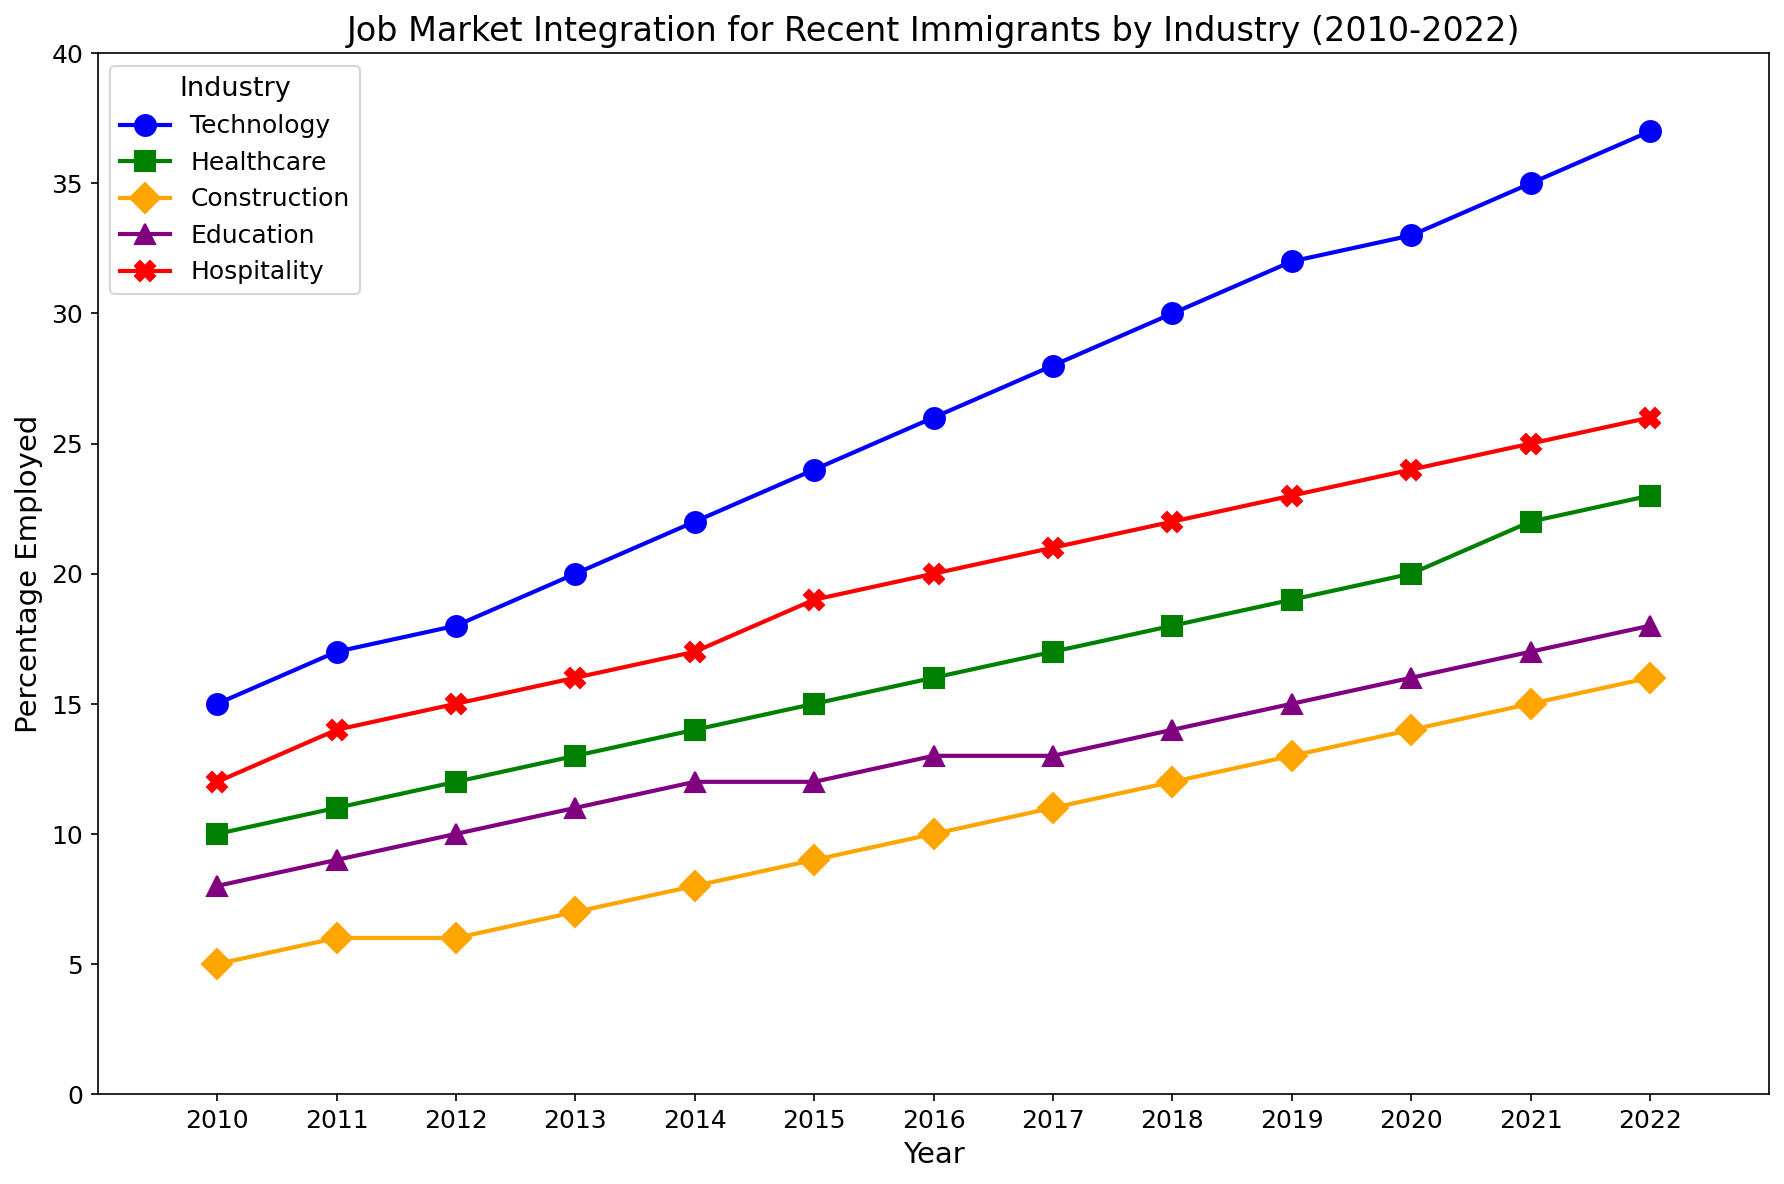Which industry had the highest percentage employed in 2022? Look at the year 2022 on the x-axis and compare the height of the lines for each industry. The line representing Technology reaches the highest point on the y-axis.
Answer: Technology Which industry saw the most significant increase in employment percentage from 2010 to 2022? Compare the percentage employed in 2010 and 2022 for each industry and find the difference. Technology increased from 15% to 37%, which is a difference of 22%.
Answer: Technology In which year did Hospitality first exceed 20% employment? Follow the Hospitality line (red with X markers) and find the year where it first crosses the 20% mark on the y-axis. This happens in 2017.
Answer: 2017 Compare the percentage employment in Education and Construction in 2015. Which one had a higher percentage? Look at the y-values for Education (purple with ^ markers) and Construction (orange with D markers) in 2015. Education is at 12%, while Construction is at 9%.
Answer: Education What is the average employment percentage in Healthcare from 2010 to 2022? Sum the employment percentages for Healthcare (green with s markers) for all years and divide by the number of years (13). (10 + 11 + 12 + 13 + 14 + 15 + 16 + 17 + 18 + 19 + 20 + 22 + 23) / 13 = 15.69%
Answer: 15.69% By how much did the employment percentage in Construction increase from 2010 to 2016? Subtract the 2010 employment percentage in Construction (5%) from the 2016 percentage (10%). 10% - 5% = 5%
Answer: 5% In which year did Technology first reach 30% employment? Trace the Technology line (blue with o markers) to see when it first hits the 30% mark on the y-axis. This occurs in 2018.
Answer: 2018 Which two industries were closest in employment percentage in 2020? Look at the employment percentages for all industries in 2020 and find the two most similar values. Construction (14%) and Education (16%) are closest, with a difference of 2%.
Answer: Construction and Education How did the employment percentage in Hospitality change from 2018 to 2022? Compare the 2018 employment percentage in Hospitality (22%) with the 2022 percentage (26%). 26% - 22% = 4% increase.
Answer: 4% Which industry had a steady increase without any dips from 2010 to 2022? Scan the lines for each industry to see which one only continuously rises. Technology, Healthcare, and Construction all rise without any dips.
Answer: Technology, Healthcare, Construction 